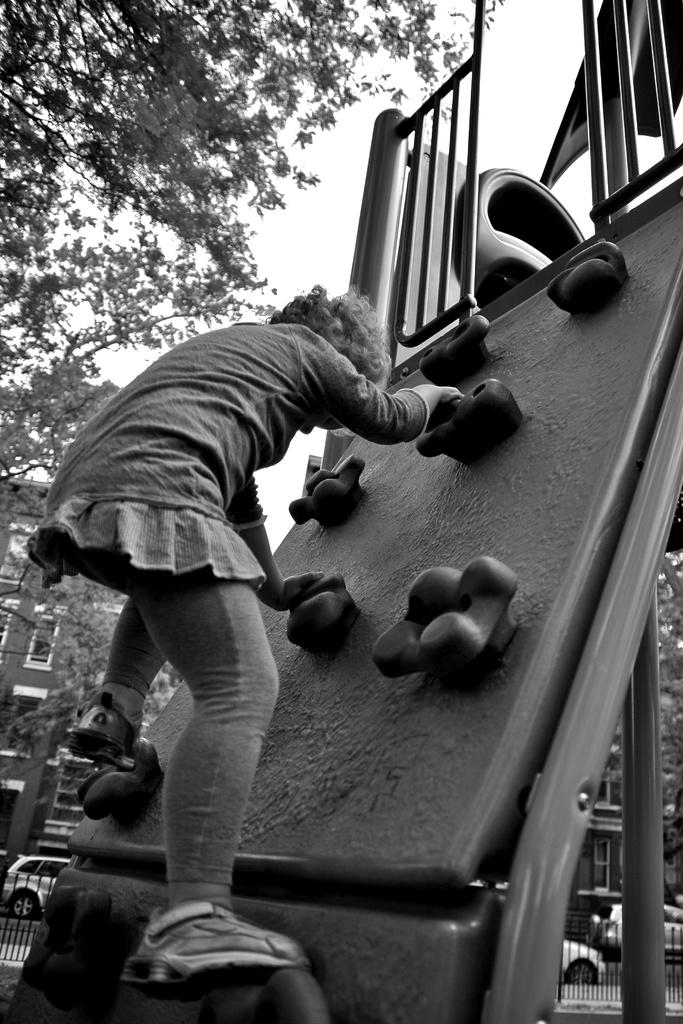What is the color scheme of the image? The image is black and white. Who is the main subject in the image? There is a girl in the image. What is the girl doing in the image? The girl is climbing a kids slide. What can be seen in the background of the image? There are buildings, trees, and vehicles visible on the road in the background of the image. What type of punishment is the girl receiving in the image? There is no indication of punishment in the image; the girl is simply climbing a kids slide. Can you tell me how many quinces are present in the image? There are no quinces present in the image. 